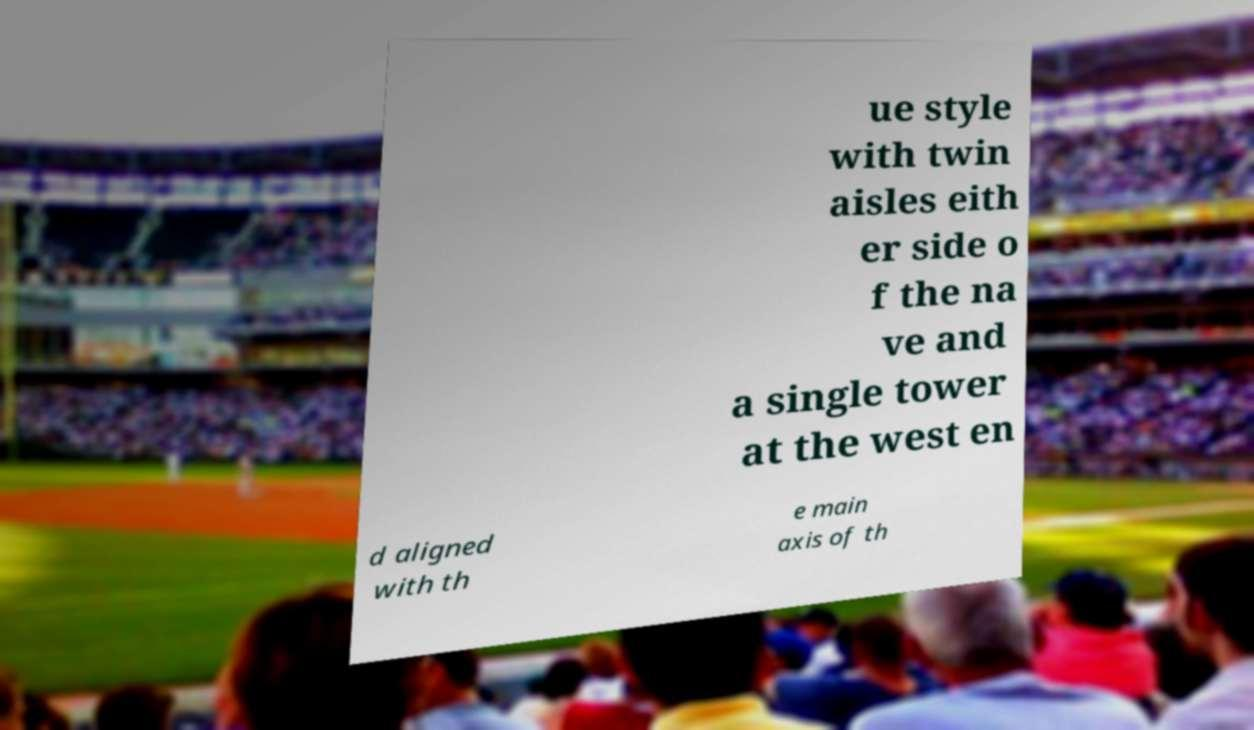I need the written content from this picture converted into text. Can you do that? ue style with twin aisles eith er side o f the na ve and a single tower at the west en d aligned with th e main axis of th 